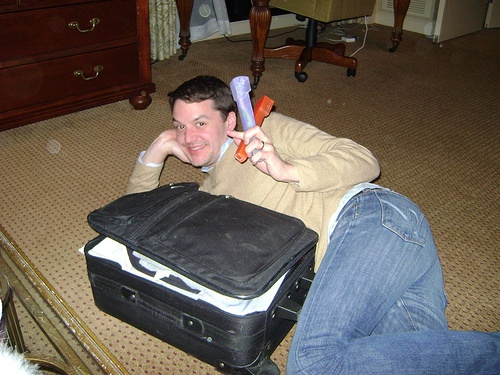Describe the objects in this image and their specific colors. I can see people in black, gray, tan, and darkgray tones, suitcase in black, gray, and white tones, and chair in black, maroon, darkgreen, and gray tones in this image. 